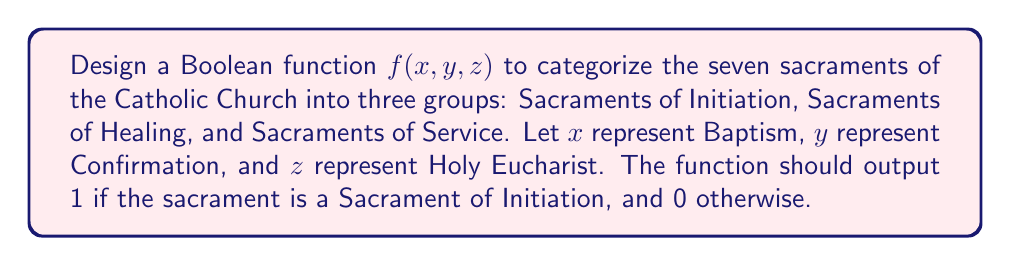What is the answer to this math problem? 1. First, let's identify the Sacraments of Initiation: Baptism, Confirmation, and Holy Eucharist.

2. We need to create a Boolean function that outputs 1 when any of these sacraments are present. This can be achieved using the OR operation.

3. The Boolean function can be expressed as:

   $$f(x, y, z) = x + y + z$$

   Where '+' represents the OR operation.

4. This function will output 1 if any of x, y, or z is 1 (representing the presence of Baptism, Confirmation, or Holy Eucharist respectively).

5. We can verify:
   - $f(1, 0, 0) = 1$ (Baptism is a Sacrament of Initiation)
   - $f(0, 1, 0) = 1$ (Confirmation is a Sacrament of Initiation)
   - $f(0, 0, 1) = 1$ (Holy Eucharist is a Sacrament of Initiation)
   - $f(0, 0, 0) = 0$ (None of the Sacraments of Initiation are present)

6. This function correctly categorizes the Sacraments of Initiation, outputting 1 when any of them are present, and 0 otherwise.
Answer: $f(x, y, z) = x + y + z$ 